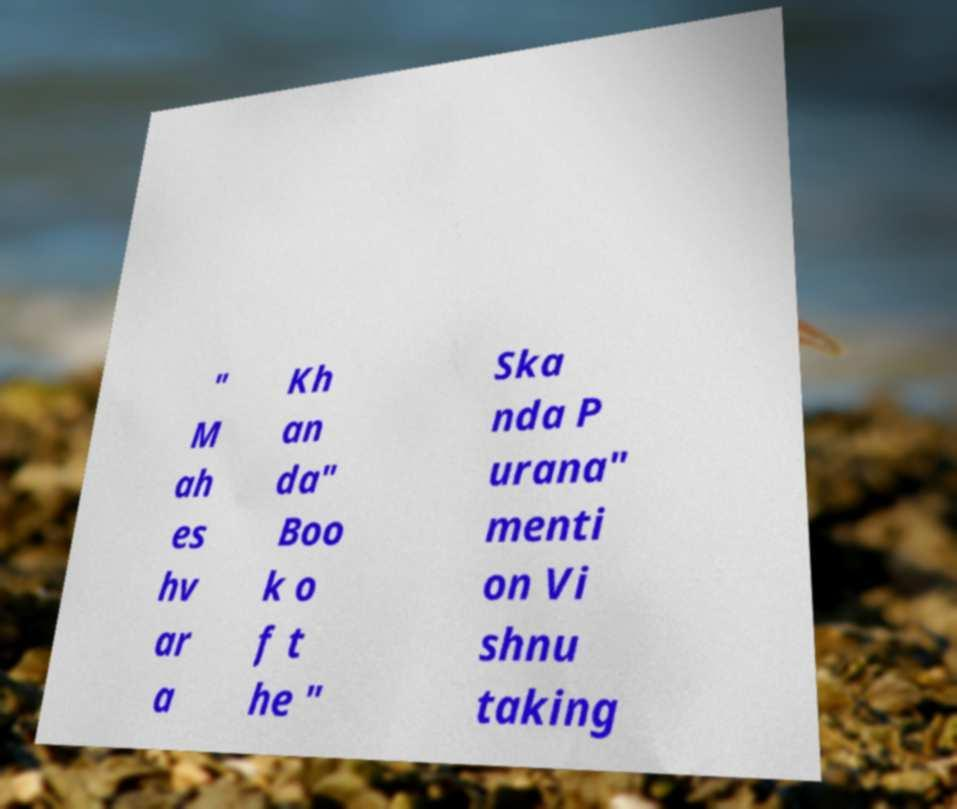Please read and relay the text visible in this image. What does it say? " M ah es hv ar a Kh an da" Boo k o f t he " Ska nda P urana" menti on Vi shnu taking 